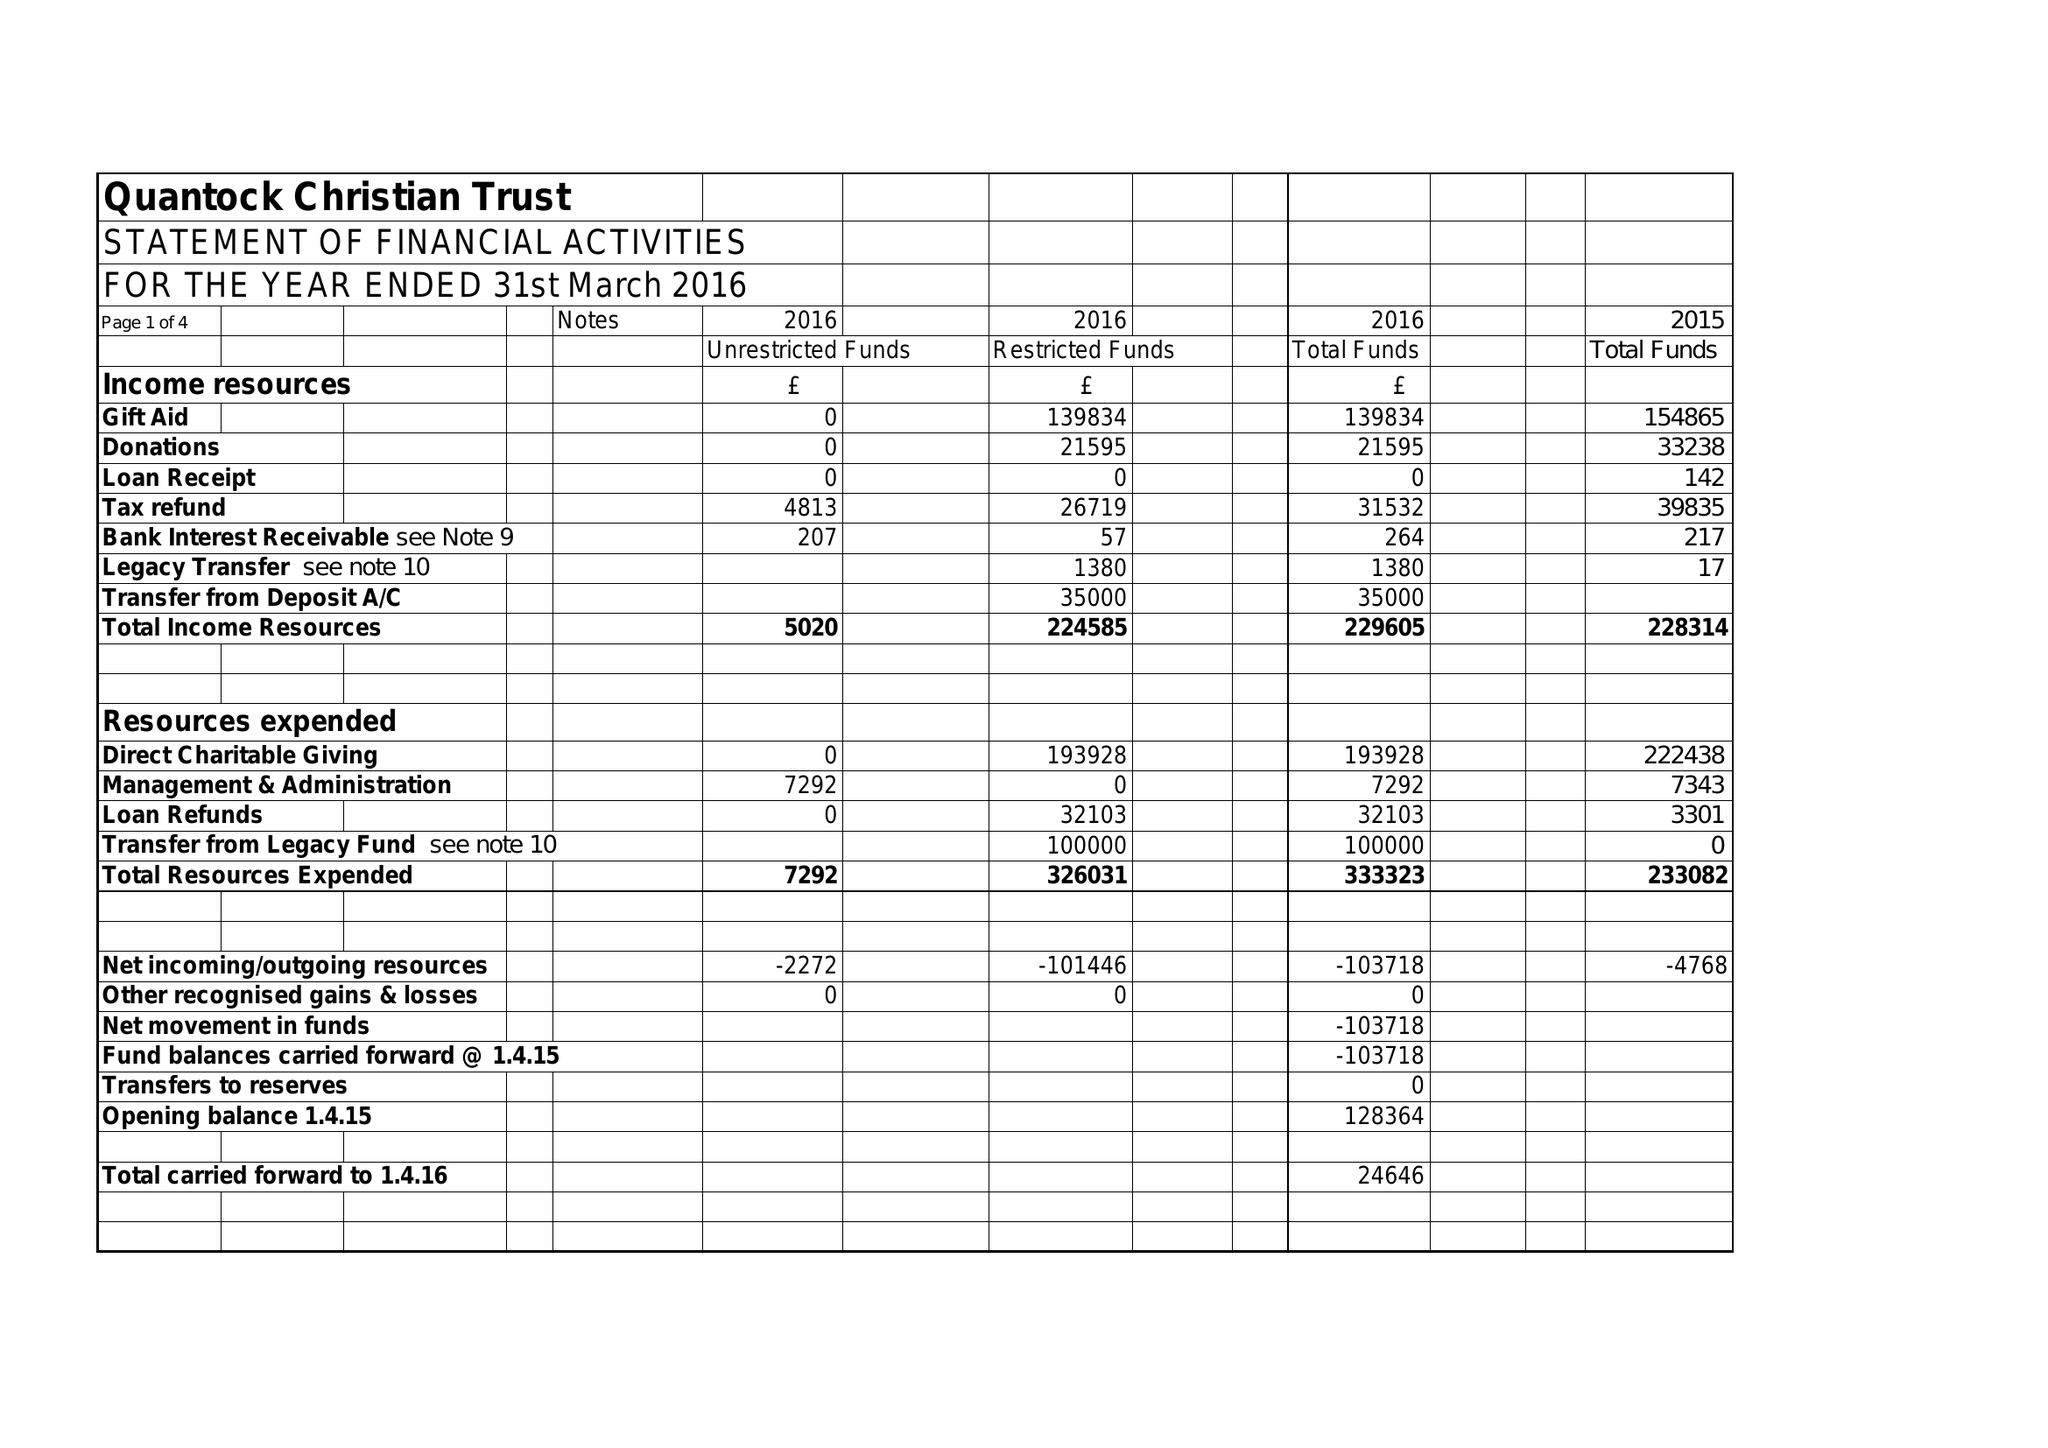What is the value for the address__postcode?
Answer the question using a single word or phrase. TA6 7JS 